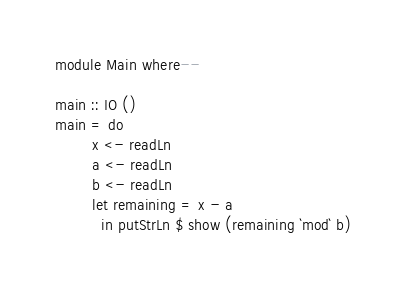<code> <loc_0><loc_0><loc_500><loc_500><_Haskell_>module Main where--

main :: IO ()
main = do
        x <- readLn
        a <- readLn
        b <- readLn
        let remaining = x - a
          in putStrLn $ show (remaining `mod` b)
</code> 